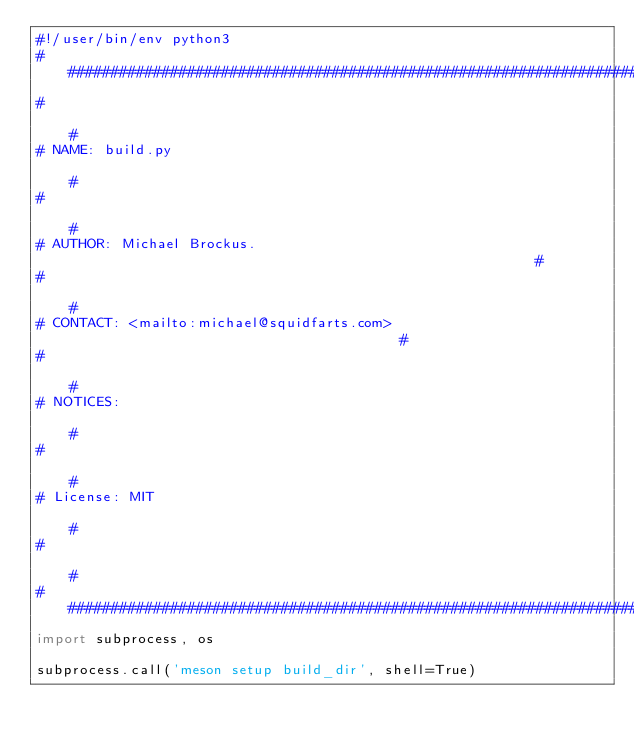<code> <loc_0><loc_0><loc_500><loc_500><_Python_>#!/user/bin/env python3
###################################################################################
#                                                                                 #
# NAME: build.py                                                                  #
#                                                                                 #
# AUTHOR: Michael Brockus.                                                        #
#                                                                                 #
# CONTACT: <mailto:michael@squidfarts.com>                                        #
#                                                                                 #
# NOTICES:                                                                        #
#                                                                                 #
# License: MIT                                                                    #
#                                                                                 #
###################################################################################
import subprocess, os

subprocess.call('meson setup build_dir', shell=True)</code> 